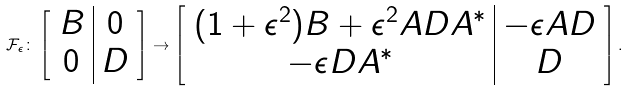<formula> <loc_0><loc_0><loc_500><loc_500>\mathcal { F } _ { \epsilon } \colon \left [ \begin{array} { c | c } B & 0 \\ 0 & D \end{array} \right ] \to \left [ \begin{array} { c | c } ( 1 + \epsilon ^ { 2 } ) B + \epsilon ^ { 2 } A D A ^ { * } & - \epsilon A D \\ - \epsilon D A ^ { * } & D \end{array} \right ] .</formula> 